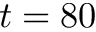<formula> <loc_0><loc_0><loc_500><loc_500>t = 8 0</formula> 